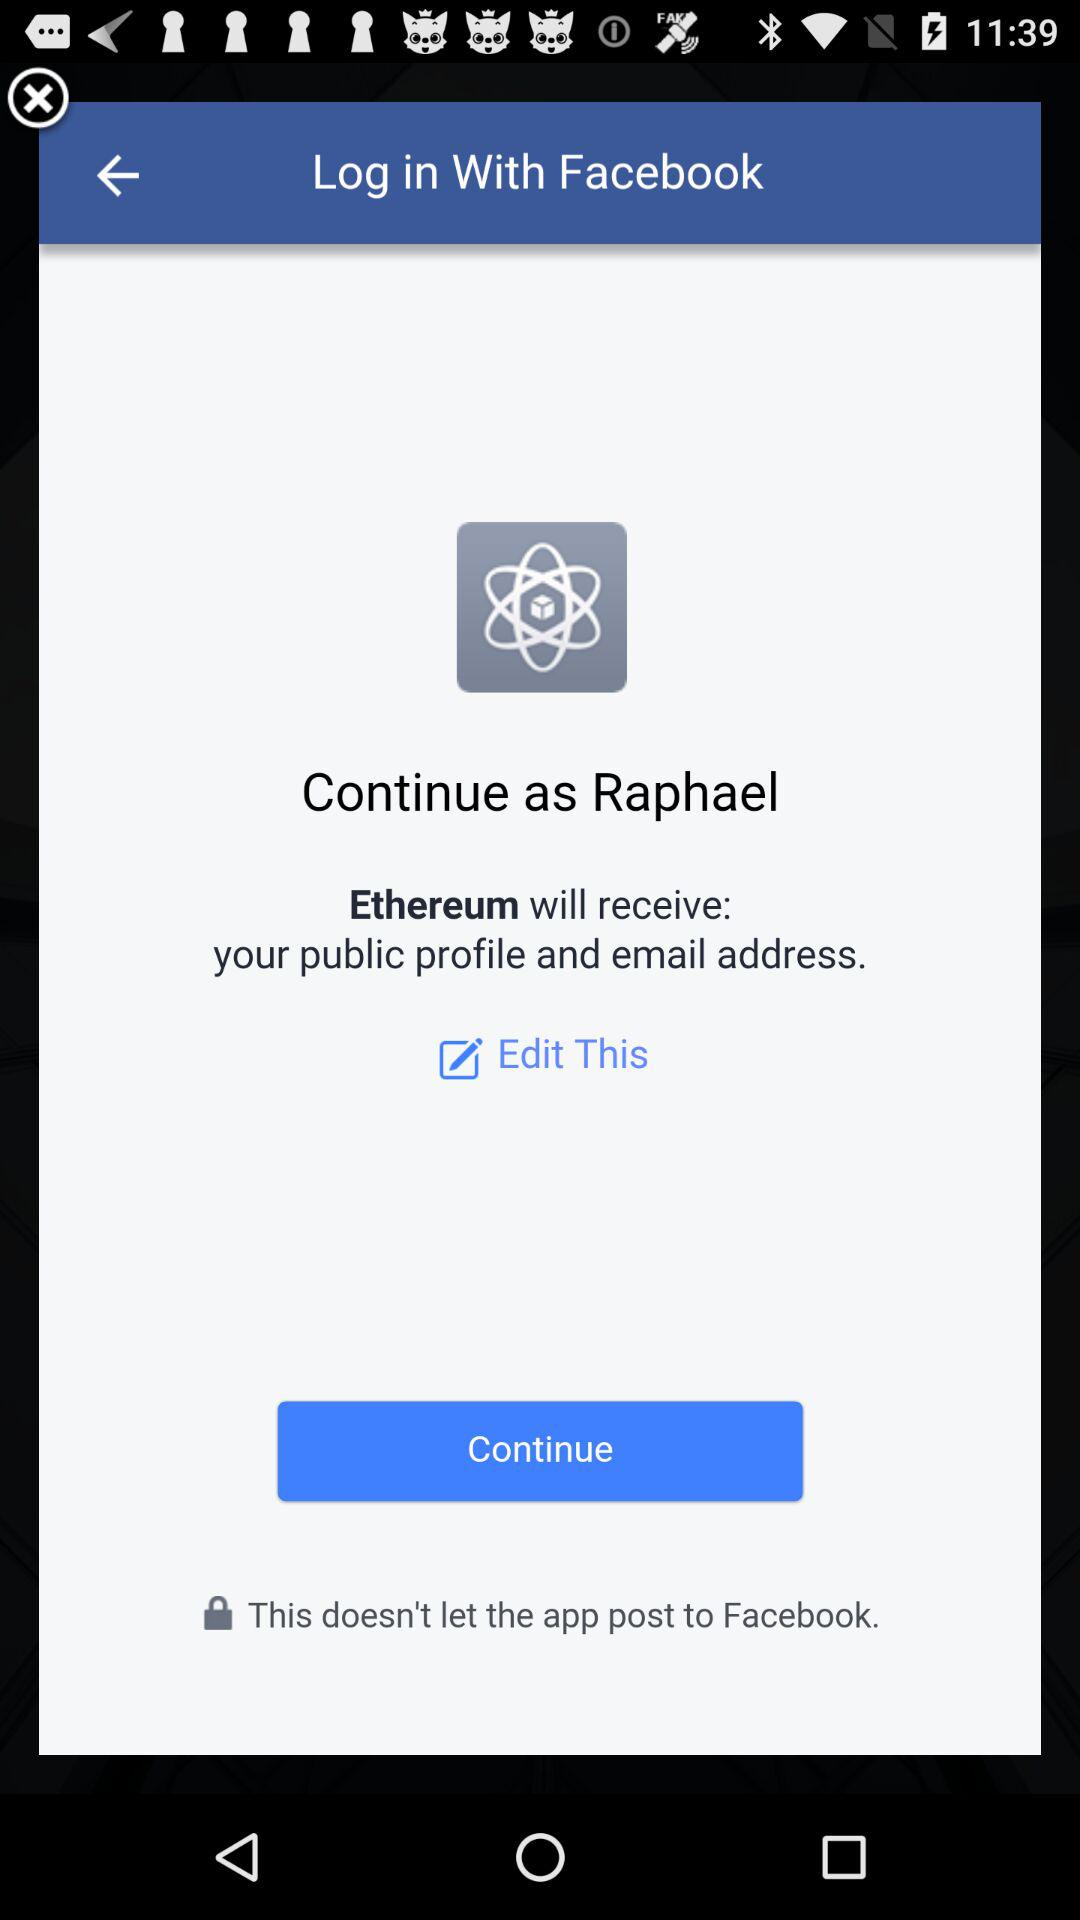What is the login name? The login name is Raphael. 